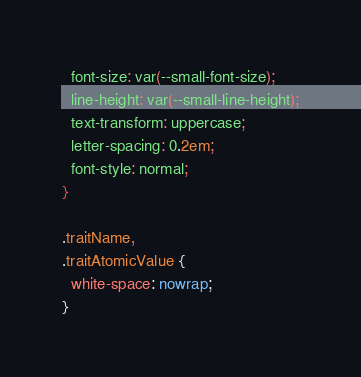<code> <loc_0><loc_0><loc_500><loc_500><_CSS_>  font-size: var(--small-font-size);
  line-height: var(--small-line-height);
  text-transform: uppercase;
  letter-spacing: 0.2em;
  font-style: normal;
}

.traitName,
.traitAtomicValue {
  white-space: nowrap;
}
</code> 